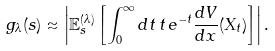Convert formula to latex. <formula><loc_0><loc_0><loc_500><loc_500>g _ { \lambda } ( s ) \approx \left | \mathbb { E } _ { s } ^ { ( \lambda ) } \left [ \int _ { 0 } ^ { \infty } d t \, t \, e ^ { - t } \frac { d V } { d x } ( X _ { t } ) \right ] \right | .</formula> 